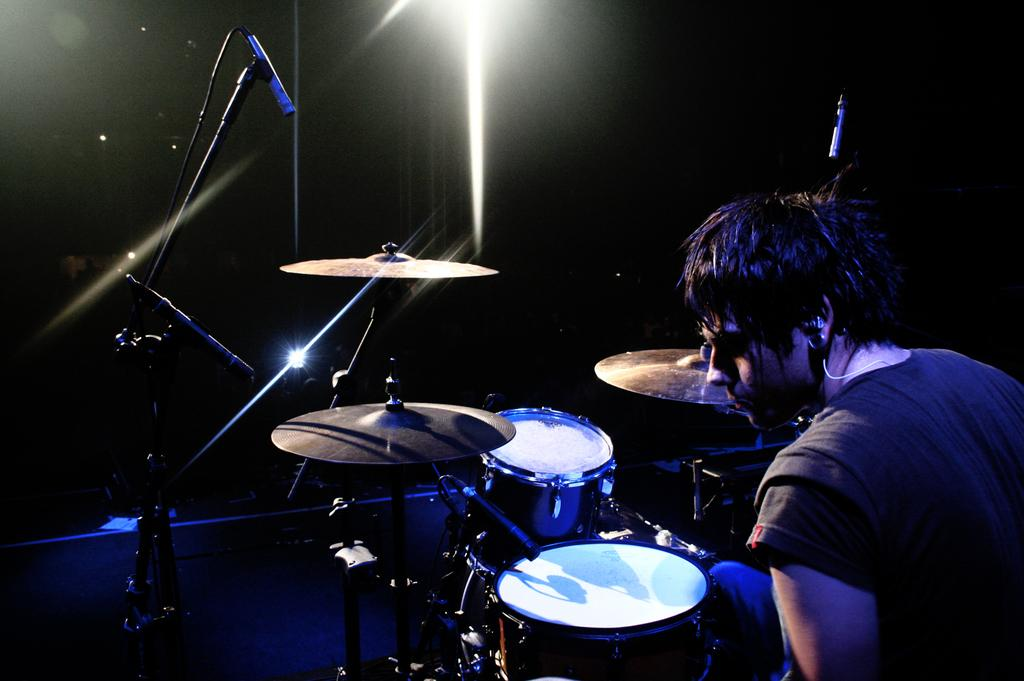Who or what is in the image? There is a person in the image. What is in front of the person? There are drums, musical instruments, and microphones in front of the person. Can you describe the lighting in the image? There is a light in the image. What type of toothbrush is the person using in the image? There is no toothbrush present in the image. Is the person lying down on a bed in the image? There is no bed present in the image, and the person is not lying down. 